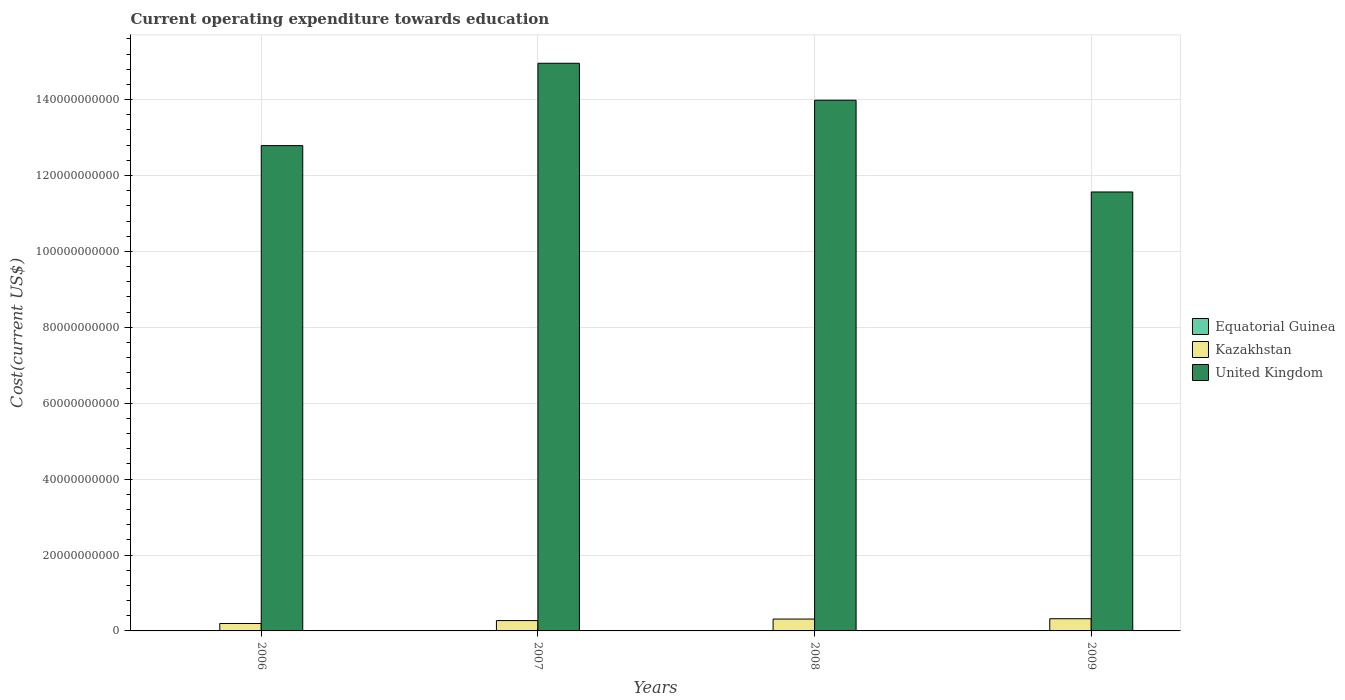How many different coloured bars are there?
Keep it short and to the point. 3. How many groups of bars are there?
Give a very brief answer. 4. Are the number of bars on each tick of the X-axis equal?
Your answer should be compact. Yes. What is the expenditure towards education in Equatorial Guinea in 2007?
Offer a terse response. 8.44e+07. Across all years, what is the maximum expenditure towards education in Kazakhstan?
Your answer should be very brief. 3.21e+09. Across all years, what is the minimum expenditure towards education in Equatorial Guinea?
Make the answer very short. 7.47e+07. In which year was the expenditure towards education in Kazakhstan minimum?
Ensure brevity in your answer.  2006. What is the total expenditure towards education in United Kingdom in the graph?
Your answer should be very brief. 5.33e+11. What is the difference between the expenditure towards education in Kazakhstan in 2006 and that in 2007?
Make the answer very short. -7.66e+08. What is the difference between the expenditure towards education in Kazakhstan in 2007 and the expenditure towards education in Equatorial Guinea in 2006?
Your answer should be very brief. 2.65e+09. What is the average expenditure towards education in Equatorial Guinea per year?
Your answer should be compact. 8.82e+07. In the year 2008, what is the difference between the expenditure towards education in United Kingdom and expenditure towards education in Kazakhstan?
Your answer should be very brief. 1.37e+11. What is the ratio of the expenditure towards education in United Kingdom in 2006 to that in 2008?
Your answer should be compact. 0.91. What is the difference between the highest and the second highest expenditure towards education in Kazakhstan?
Offer a terse response. 8.75e+07. What is the difference between the highest and the lowest expenditure towards education in Equatorial Guinea?
Ensure brevity in your answer.  2.88e+07. Is the sum of the expenditure towards education in United Kingdom in 2007 and 2009 greater than the maximum expenditure towards education in Equatorial Guinea across all years?
Provide a succinct answer. Yes. What does the 2nd bar from the right in 2006 represents?
Provide a short and direct response. Kazakhstan. Is it the case that in every year, the sum of the expenditure towards education in United Kingdom and expenditure towards education in Kazakhstan is greater than the expenditure towards education in Equatorial Guinea?
Your response must be concise. Yes. Are all the bars in the graph horizontal?
Your answer should be very brief. No. Are the values on the major ticks of Y-axis written in scientific E-notation?
Your answer should be compact. No. Does the graph contain any zero values?
Keep it short and to the point. No. How many legend labels are there?
Provide a succinct answer. 3. What is the title of the graph?
Provide a succinct answer. Current operating expenditure towards education. What is the label or title of the Y-axis?
Make the answer very short. Cost(current US$). What is the Cost(current US$) in Equatorial Guinea in 2006?
Give a very brief answer. 7.47e+07. What is the Cost(current US$) of Kazakhstan in 2006?
Your answer should be very brief. 1.96e+09. What is the Cost(current US$) in United Kingdom in 2006?
Your answer should be very brief. 1.28e+11. What is the Cost(current US$) of Equatorial Guinea in 2007?
Give a very brief answer. 8.44e+07. What is the Cost(current US$) of Kazakhstan in 2007?
Give a very brief answer. 2.73e+09. What is the Cost(current US$) of United Kingdom in 2007?
Make the answer very short. 1.50e+11. What is the Cost(current US$) of Equatorial Guinea in 2008?
Make the answer very short. 1.03e+08. What is the Cost(current US$) of Kazakhstan in 2008?
Your answer should be compact. 3.12e+09. What is the Cost(current US$) of United Kingdom in 2008?
Provide a short and direct response. 1.40e+11. What is the Cost(current US$) in Equatorial Guinea in 2009?
Provide a succinct answer. 9.05e+07. What is the Cost(current US$) of Kazakhstan in 2009?
Make the answer very short. 3.21e+09. What is the Cost(current US$) of United Kingdom in 2009?
Offer a terse response. 1.16e+11. Across all years, what is the maximum Cost(current US$) of Equatorial Guinea?
Your answer should be compact. 1.03e+08. Across all years, what is the maximum Cost(current US$) in Kazakhstan?
Your answer should be very brief. 3.21e+09. Across all years, what is the maximum Cost(current US$) in United Kingdom?
Offer a terse response. 1.50e+11. Across all years, what is the minimum Cost(current US$) in Equatorial Guinea?
Your answer should be compact. 7.47e+07. Across all years, what is the minimum Cost(current US$) in Kazakhstan?
Your response must be concise. 1.96e+09. Across all years, what is the minimum Cost(current US$) in United Kingdom?
Offer a terse response. 1.16e+11. What is the total Cost(current US$) of Equatorial Guinea in the graph?
Your response must be concise. 3.53e+08. What is the total Cost(current US$) of Kazakhstan in the graph?
Keep it short and to the point. 1.10e+1. What is the total Cost(current US$) of United Kingdom in the graph?
Provide a short and direct response. 5.33e+11. What is the difference between the Cost(current US$) in Equatorial Guinea in 2006 and that in 2007?
Provide a succinct answer. -9.70e+06. What is the difference between the Cost(current US$) in Kazakhstan in 2006 and that in 2007?
Your response must be concise. -7.66e+08. What is the difference between the Cost(current US$) of United Kingdom in 2006 and that in 2007?
Provide a succinct answer. -2.17e+1. What is the difference between the Cost(current US$) in Equatorial Guinea in 2006 and that in 2008?
Ensure brevity in your answer.  -2.88e+07. What is the difference between the Cost(current US$) of Kazakhstan in 2006 and that in 2008?
Offer a very short reply. -1.17e+09. What is the difference between the Cost(current US$) of United Kingdom in 2006 and that in 2008?
Offer a terse response. -1.20e+1. What is the difference between the Cost(current US$) in Equatorial Guinea in 2006 and that in 2009?
Ensure brevity in your answer.  -1.58e+07. What is the difference between the Cost(current US$) of Kazakhstan in 2006 and that in 2009?
Offer a very short reply. -1.25e+09. What is the difference between the Cost(current US$) in United Kingdom in 2006 and that in 2009?
Your response must be concise. 1.22e+1. What is the difference between the Cost(current US$) in Equatorial Guinea in 2007 and that in 2008?
Give a very brief answer. -1.91e+07. What is the difference between the Cost(current US$) of Kazakhstan in 2007 and that in 2008?
Provide a short and direct response. -4.00e+08. What is the difference between the Cost(current US$) in United Kingdom in 2007 and that in 2008?
Keep it short and to the point. 9.74e+09. What is the difference between the Cost(current US$) in Equatorial Guinea in 2007 and that in 2009?
Keep it short and to the point. -6.12e+06. What is the difference between the Cost(current US$) in Kazakhstan in 2007 and that in 2009?
Offer a terse response. -4.87e+08. What is the difference between the Cost(current US$) in United Kingdom in 2007 and that in 2009?
Your answer should be compact. 3.39e+1. What is the difference between the Cost(current US$) in Equatorial Guinea in 2008 and that in 2009?
Offer a terse response. 1.30e+07. What is the difference between the Cost(current US$) in Kazakhstan in 2008 and that in 2009?
Offer a very short reply. -8.75e+07. What is the difference between the Cost(current US$) of United Kingdom in 2008 and that in 2009?
Your response must be concise. 2.42e+1. What is the difference between the Cost(current US$) in Equatorial Guinea in 2006 and the Cost(current US$) in Kazakhstan in 2007?
Your answer should be very brief. -2.65e+09. What is the difference between the Cost(current US$) of Equatorial Guinea in 2006 and the Cost(current US$) of United Kingdom in 2007?
Ensure brevity in your answer.  -1.49e+11. What is the difference between the Cost(current US$) of Kazakhstan in 2006 and the Cost(current US$) of United Kingdom in 2007?
Ensure brevity in your answer.  -1.48e+11. What is the difference between the Cost(current US$) of Equatorial Guinea in 2006 and the Cost(current US$) of Kazakhstan in 2008?
Provide a short and direct response. -3.05e+09. What is the difference between the Cost(current US$) of Equatorial Guinea in 2006 and the Cost(current US$) of United Kingdom in 2008?
Your answer should be very brief. -1.40e+11. What is the difference between the Cost(current US$) of Kazakhstan in 2006 and the Cost(current US$) of United Kingdom in 2008?
Your response must be concise. -1.38e+11. What is the difference between the Cost(current US$) in Equatorial Guinea in 2006 and the Cost(current US$) in Kazakhstan in 2009?
Keep it short and to the point. -3.14e+09. What is the difference between the Cost(current US$) in Equatorial Guinea in 2006 and the Cost(current US$) in United Kingdom in 2009?
Your response must be concise. -1.16e+11. What is the difference between the Cost(current US$) in Kazakhstan in 2006 and the Cost(current US$) in United Kingdom in 2009?
Provide a succinct answer. -1.14e+11. What is the difference between the Cost(current US$) in Equatorial Guinea in 2007 and the Cost(current US$) in Kazakhstan in 2008?
Provide a succinct answer. -3.04e+09. What is the difference between the Cost(current US$) of Equatorial Guinea in 2007 and the Cost(current US$) of United Kingdom in 2008?
Your answer should be very brief. -1.40e+11. What is the difference between the Cost(current US$) in Kazakhstan in 2007 and the Cost(current US$) in United Kingdom in 2008?
Provide a succinct answer. -1.37e+11. What is the difference between the Cost(current US$) in Equatorial Guinea in 2007 and the Cost(current US$) in Kazakhstan in 2009?
Ensure brevity in your answer.  -3.13e+09. What is the difference between the Cost(current US$) in Equatorial Guinea in 2007 and the Cost(current US$) in United Kingdom in 2009?
Your answer should be very brief. -1.16e+11. What is the difference between the Cost(current US$) of Kazakhstan in 2007 and the Cost(current US$) of United Kingdom in 2009?
Ensure brevity in your answer.  -1.13e+11. What is the difference between the Cost(current US$) in Equatorial Guinea in 2008 and the Cost(current US$) in Kazakhstan in 2009?
Make the answer very short. -3.11e+09. What is the difference between the Cost(current US$) of Equatorial Guinea in 2008 and the Cost(current US$) of United Kingdom in 2009?
Offer a terse response. -1.16e+11. What is the difference between the Cost(current US$) of Kazakhstan in 2008 and the Cost(current US$) of United Kingdom in 2009?
Provide a succinct answer. -1.13e+11. What is the average Cost(current US$) in Equatorial Guinea per year?
Keep it short and to the point. 8.82e+07. What is the average Cost(current US$) of Kazakhstan per year?
Provide a short and direct response. 2.76e+09. What is the average Cost(current US$) of United Kingdom per year?
Make the answer very short. 1.33e+11. In the year 2006, what is the difference between the Cost(current US$) in Equatorial Guinea and Cost(current US$) in Kazakhstan?
Keep it short and to the point. -1.88e+09. In the year 2006, what is the difference between the Cost(current US$) of Equatorial Guinea and Cost(current US$) of United Kingdom?
Provide a succinct answer. -1.28e+11. In the year 2006, what is the difference between the Cost(current US$) of Kazakhstan and Cost(current US$) of United Kingdom?
Provide a short and direct response. -1.26e+11. In the year 2007, what is the difference between the Cost(current US$) in Equatorial Guinea and Cost(current US$) in Kazakhstan?
Your answer should be very brief. -2.64e+09. In the year 2007, what is the difference between the Cost(current US$) in Equatorial Guinea and Cost(current US$) in United Kingdom?
Your answer should be compact. -1.49e+11. In the year 2007, what is the difference between the Cost(current US$) in Kazakhstan and Cost(current US$) in United Kingdom?
Make the answer very short. -1.47e+11. In the year 2008, what is the difference between the Cost(current US$) in Equatorial Guinea and Cost(current US$) in Kazakhstan?
Offer a very short reply. -3.02e+09. In the year 2008, what is the difference between the Cost(current US$) of Equatorial Guinea and Cost(current US$) of United Kingdom?
Make the answer very short. -1.40e+11. In the year 2008, what is the difference between the Cost(current US$) of Kazakhstan and Cost(current US$) of United Kingdom?
Your answer should be compact. -1.37e+11. In the year 2009, what is the difference between the Cost(current US$) of Equatorial Guinea and Cost(current US$) of Kazakhstan?
Give a very brief answer. -3.12e+09. In the year 2009, what is the difference between the Cost(current US$) in Equatorial Guinea and Cost(current US$) in United Kingdom?
Your answer should be compact. -1.16e+11. In the year 2009, what is the difference between the Cost(current US$) of Kazakhstan and Cost(current US$) of United Kingdom?
Offer a terse response. -1.12e+11. What is the ratio of the Cost(current US$) in Equatorial Guinea in 2006 to that in 2007?
Keep it short and to the point. 0.89. What is the ratio of the Cost(current US$) in Kazakhstan in 2006 to that in 2007?
Offer a very short reply. 0.72. What is the ratio of the Cost(current US$) of United Kingdom in 2006 to that in 2007?
Ensure brevity in your answer.  0.85. What is the ratio of the Cost(current US$) in Equatorial Guinea in 2006 to that in 2008?
Your response must be concise. 0.72. What is the ratio of the Cost(current US$) in Kazakhstan in 2006 to that in 2008?
Give a very brief answer. 0.63. What is the ratio of the Cost(current US$) in United Kingdom in 2006 to that in 2008?
Ensure brevity in your answer.  0.91. What is the ratio of the Cost(current US$) of Equatorial Guinea in 2006 to that in 2009?
Provide a short and direct response. 0.83. What is the ratio of the Cost(current US$) of Kazakhstan in 2006 to that in 2009?
Give a very brief answer. 0.61. What is the ratio of the Cost(current US$) of United Kingdom in 2006 to that in 2009?
Give a very brief answer. 1.11. What is the ratio of the Cost(current US$) of Equatorial Guinea in 2007 to that in 2008?
Make the answer very short. 0.82. What is the ratio of the Cost(current US$) in Kazakhstan in 2007 to that in 2008?
Your answer should be compact. 0.87. What is the ratio of the Cost(current US$) in United Kingdom in 2007 to that in 2008?
Give a very brief answer. 1.07. What is the ratio of the Cost(current US$) of Equatorial Guinea in 2007 to that in 2009?
Offer a terse response. 0.93. What is the ratio of the Cost(current US$) in Kazakhstan in 2007 to that in 2009?
Offer a very short reply. 0.85. What is the ratio of the Cost(current US$) in United Kingdom in 2007 to that in 2009?
Ensure brevity in your answer.  1.29. What is the ratio of the Cost(current US$) in Equatorial Guinea in 2008 to that in 2009?
Give a very brief answer. 1.14. What is the ratio of the Cost(current US$) in Kazakhstan in 2008 to that in 2009?
Provide a succinct answer. 0.97. What is the ratio of the Cost(current US$) in United Kingdom in 2008 to that in 2009?
Your response must be concise. 1.21. What is the difference between the highest and the second highest Cost(current US$) of Equatorial Guinea?
Make the answer very short. 1.30e+07. What is the difference between the highest and the second highest Cost(current US$) of Kazakhstan?
Make the answer very short. 8.75e+07. What is the difference between the highest and the second highest Cost(current US$) in United Kingdom?
Offer a very short reply. 9.74e+09. What is the difference between the highest and the lowest Cost(current US$) in Equatorial Guinea?
Your answer should be compact. 2.88e+07. What is the difference between the highest and the lowest Cost(current US$) of Kazakhstan?
Your answer should be compact. 1.25e+09. What is the difference between the highest and the lowest Cost(current US$) in United Kingdom?
Your response must be concise. 3.39e+1. 